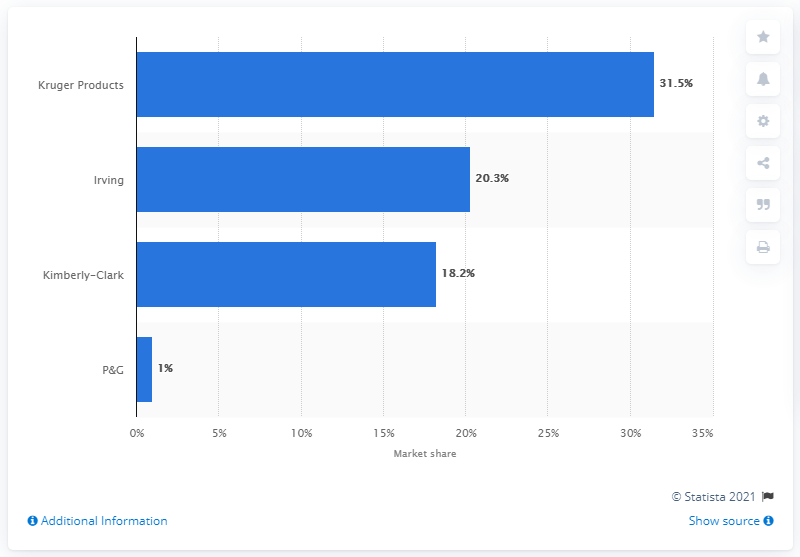Identify some key points in this picture. Kruger Products is also known as KP Tissue. In 2022, Kruger Products had a market share of 31.5%. 